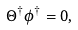Convert formula to latex. <formula><loc_0><loc_0><loc_500><loc_500>\Theta ^ { \dagger } \phi ^ { \dagger } = 0 ,</formula> 